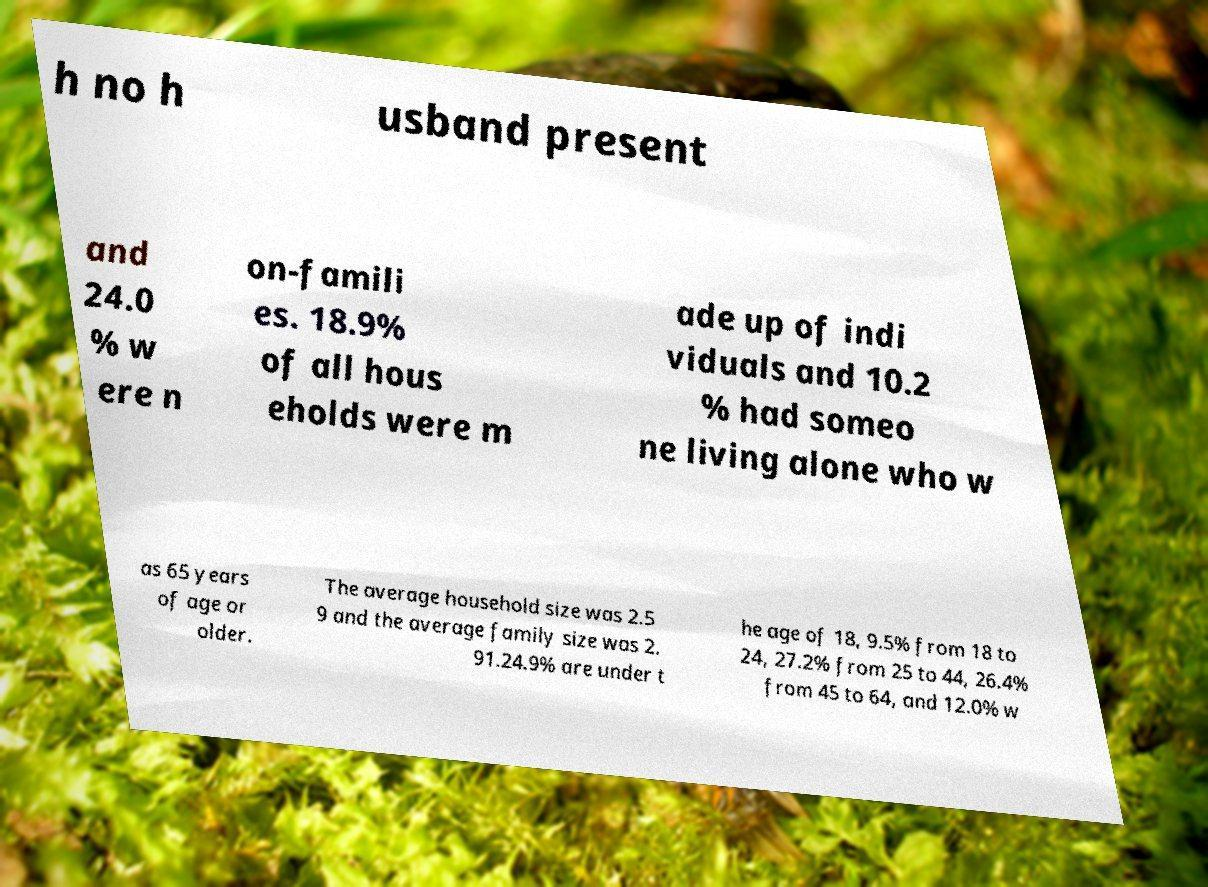Can you accurately transcribe the text from the provided image for me? h no h usband present and 24.0 % w ere n on-famili es. 18.9% of all hous eholds were m ade up of indi viduals and 10.2 % had someo ne living alone who w as 65 years of age or older. The average household size was 2.5 9 and the average family size was 2. 91.24.9% are under t he age of 18, 9.5% from 18 to 24, 27.2% from 25 to 44, 26.4% from 45 to 64, and 12.0% w 